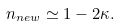Convert formula to latex. <formula><loc_0><loc_0><loc_500><loc_500>n _ { n e w } \simeq 1 - 2 \kappa .</formula> 